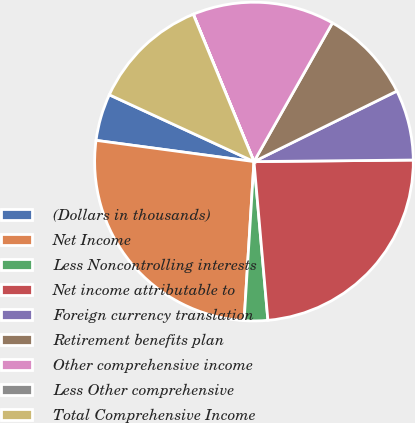Convert chart. <chart><loc_0><loc_0><loc_500><loc_500><pie_chart><fcel>(Dollars in thousands)<fcel>Net Income<fcel>Less Noncontrolling interests<fcel>Net income attributable to<fcel>Foreign currency translation<fcel>Retirement benefits plan<fcel>Other comprehensive income<fcel>Less Other comprehensive<fcel>Total Comprehensive Income<nl><fcel>4.76%<fcel>26.14%<fcel>2.38%<fcel>23.76%<fcel>7.14%<fcel>9.51%<fcel>14.41%<fcel>0.01%<fcel>11.89%<nl></chart> 